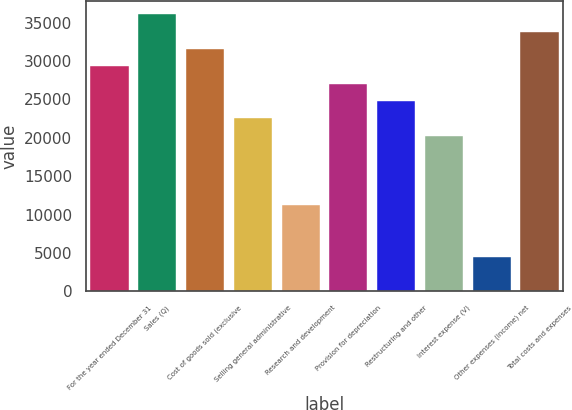Convert chart to OTSL. <chart><loc_0><loc_0><loc_500><loc_500><bar_chart><fcel>For the year ended December 31<fcel>Sales (Q)<fcel>Cost of goods sold (exclusive<fcel>Selling general administrative<fcel>Research and development<fcel>Provision for depreciation<fcel>Restructuring and other<fcel>Interest expense (V)<fcel>Other expenses (income) net<fcel>Total costs and expenses<nl><fcel>29294.1<fcel>36054.2<fcel>31547.5<fcel>22534<fcel>11267.2<fcel>27040.8<fcel>24787.4<fcel>20280.6<fcel>4507.05<fcel>33800.9<nl></chart> 